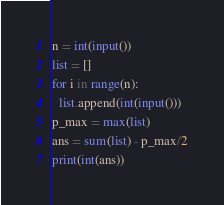<code> <loc_0><loc_0><loc_500><loc_500><_Python_>n = int(input())
list = []
for i in range(n):
  list.append(int(input()))
p_max = max(list)
ans = sum(list) - p_max/2
print(int(ans))</code> 